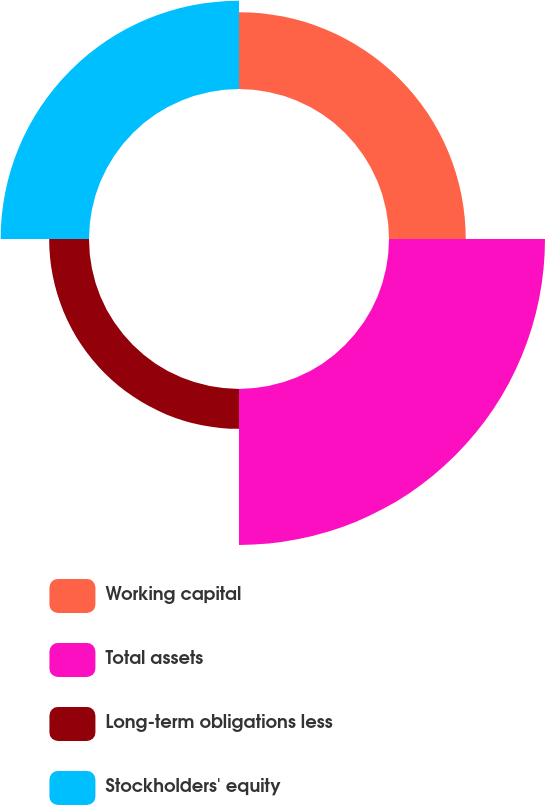Convert chart to OTSL. <chart><loc_0><loc_0><loc_500><loc_500><pie_chart><fcel>Working capital<fcel>Total assets<fcel>Long-term obligations less<fcel>Stockholders' equity<nl><fcel>21.26%<fcel>43.22%<fcel>11.04%<fcel>24.48%<nl></chart> 